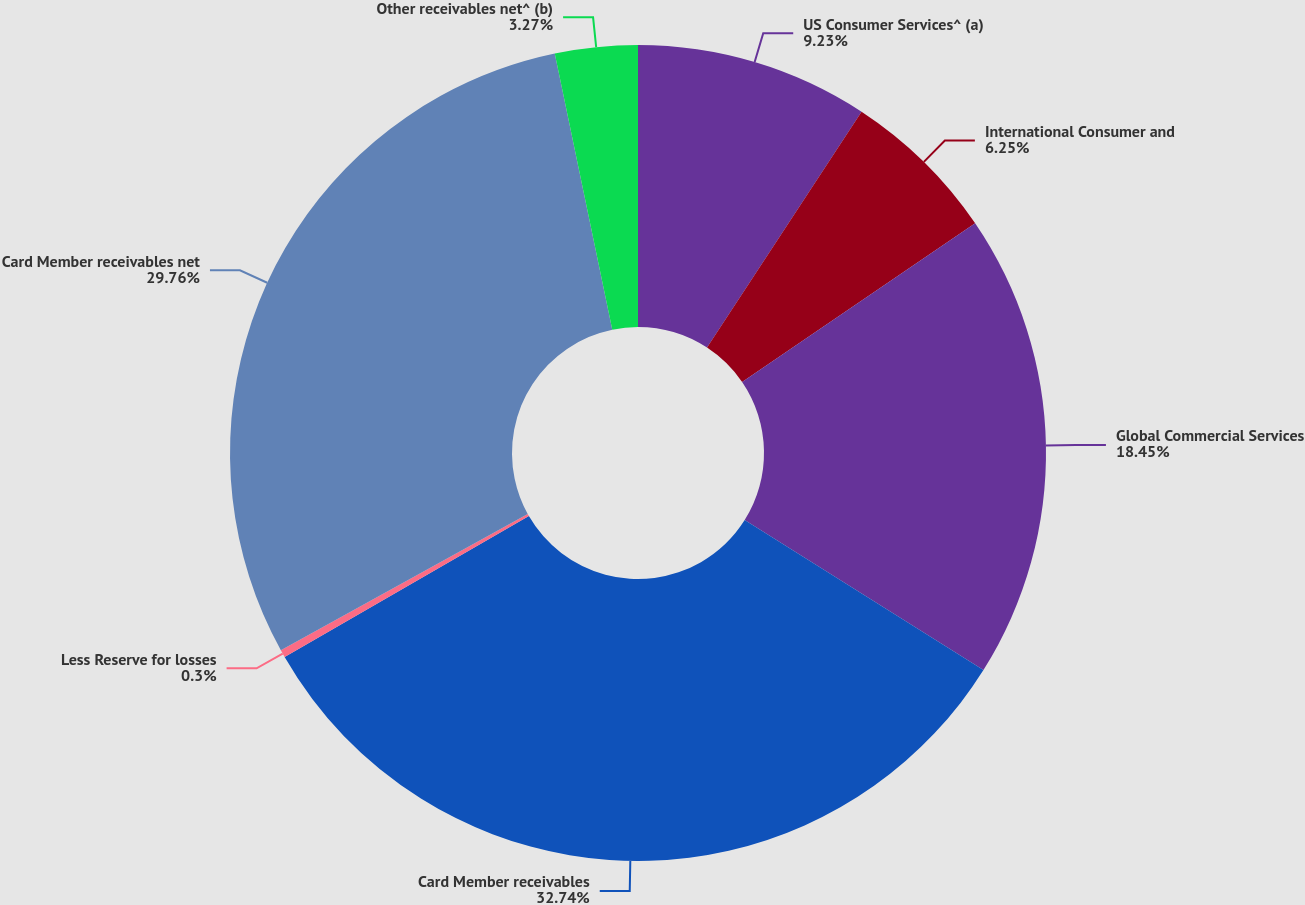Convert chart. <chart><loc_0><loc_0><loc_500><loc_500><pie_chart><fcel>US Consumer Services^ (a)<fcel>International Consumer and<fcel>Global Commercial Services<fcel>Card Member receivables<fcel>Less Reserve for losses<fcel>Card Member receivables net<fcel>Other receivables net^ (b)<nl><fcel>9.23%<fcel>6.25%<fcel>18.45%<fcel>32.74%<fcel>0.3%<fcel>29.76%<fcel>3.27%<nl></chart> 